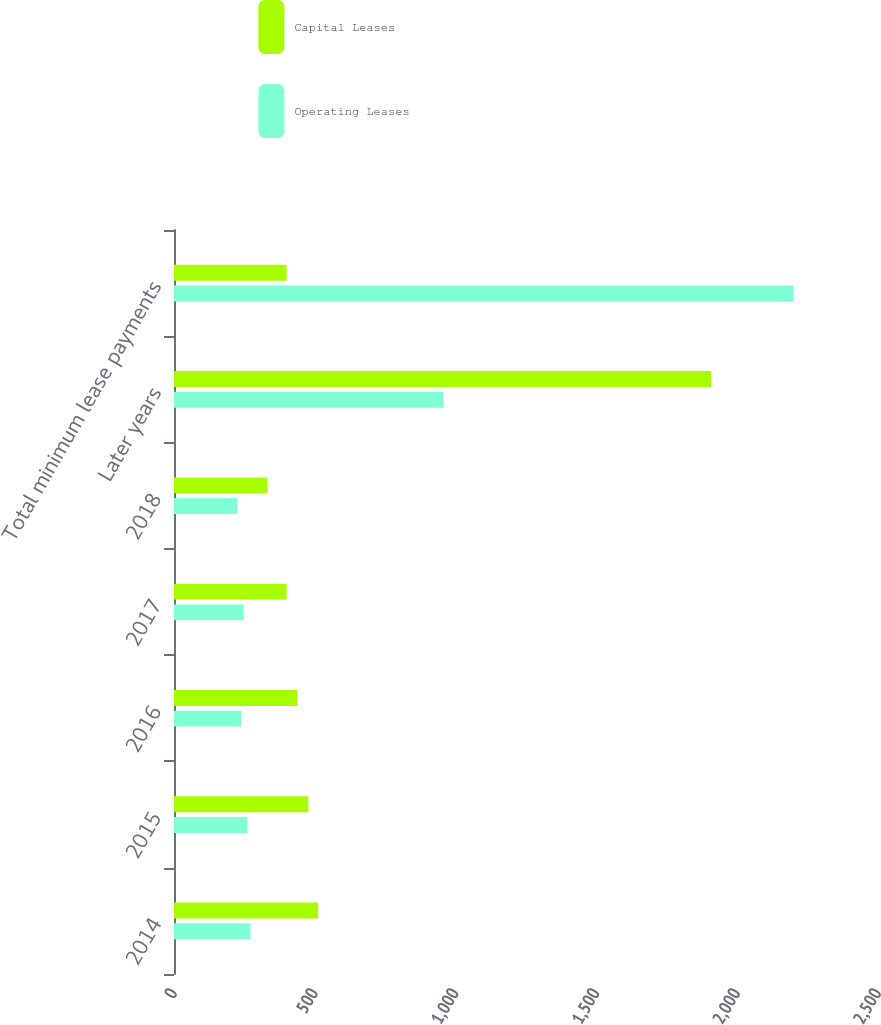<chart> <loc_0><loc_0><loc_500><loc_500><stacked_bar_chart><ecel><fcel>2014<fcel>2015<fcel>2016<fcel>2017<fcel>2018<fcel>Later years<fcel>Total minimum lease payments<nl><fcel>Capital Leases<fcel>512<fcel>477<fcel>438<fcel>400<fcel>332<fcel>1907<fcel>400<nl><fcel>Operating Leases<fcel>272<fcel>260<fcel>239<fcel>247<fcel>225<fcel>957<fcel>2200<nl></chart> 